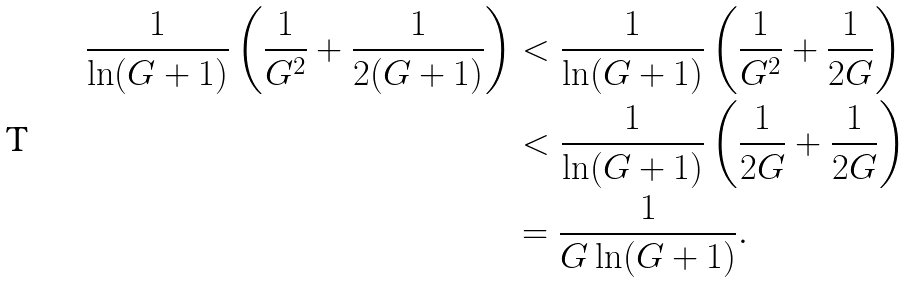<formula> <loc_0><loc_0><loc_500><loc_500>\frac { 1 } { \ln ( G + 1 ) } \left ( \frac { 1 } { G ^ { 2 } } + \frac { 1 } { 2 ( G + 1 ) } \right ) & < \frac { 1 } { \ln ( G + 1 ) } \left ( \frac { 1 } { G ^ { 2 } } + \frac { 1 } { 2 G } \right ) \\ & < \frac { 1 } { \ln ( G + 1 ) } \left ( \frac { 1 } { 2 G } + \frac { 1 } { 2 G } \right ) \\ & = \frac { 1 } { G \ln ( G + 1 ) } .</formula> 